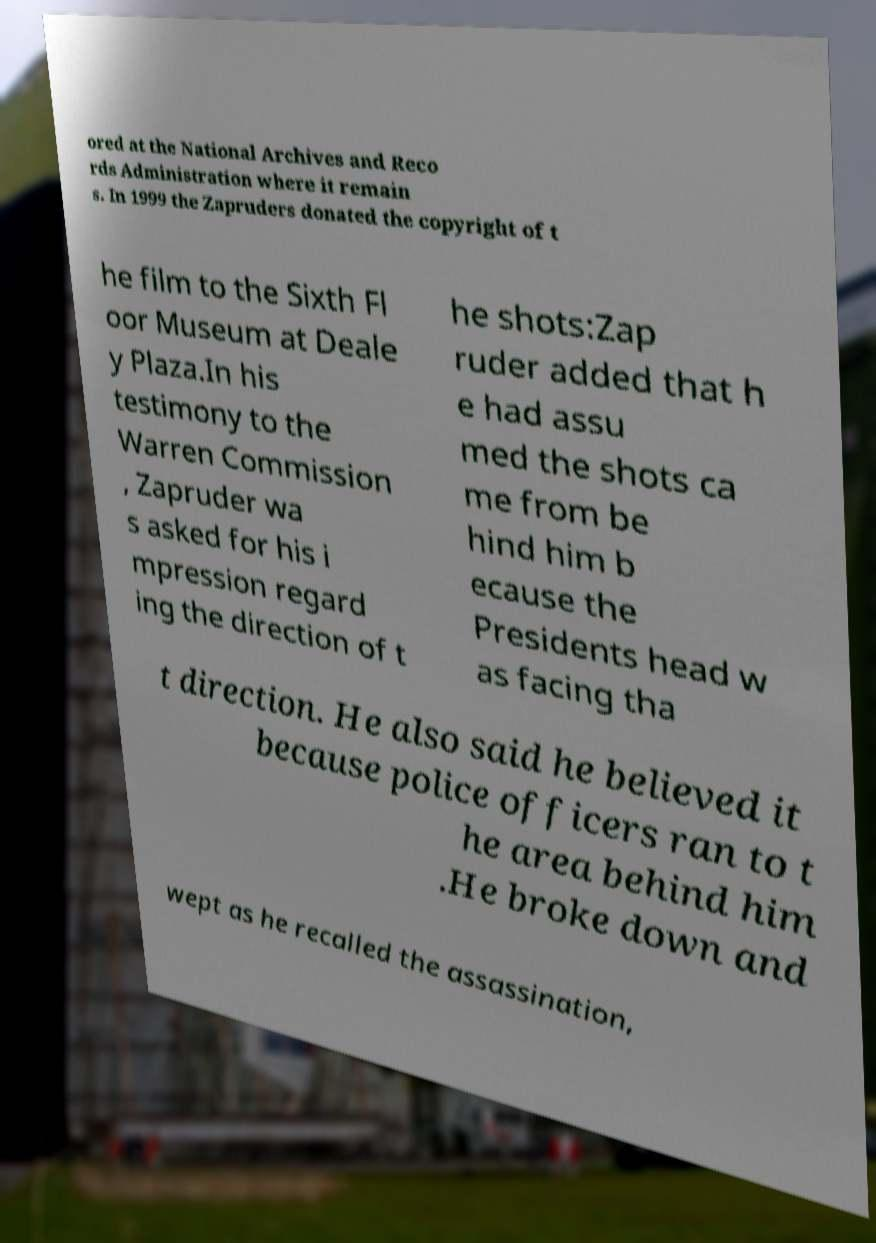Can you accurately transcribe the text from the provided image for me? ored at the National Archives and Reco rds Administration where it remain s. In 1999 the Zapruders donated the copyright of t he film to the Sixth Fl oor Museum at Deale y Plaza.In his testimony to the Warren Commission , Zapruder wa s asked for his i mpression regard ing the direction of t he shots:Zap ruder added that h e had assu med the shots ca me from be hind him b ecause the Presidents head w as facing tha t direction. He also said he believed it because police officers ran to t he area behind him .He broke down and wept as he recalled the assassination, 